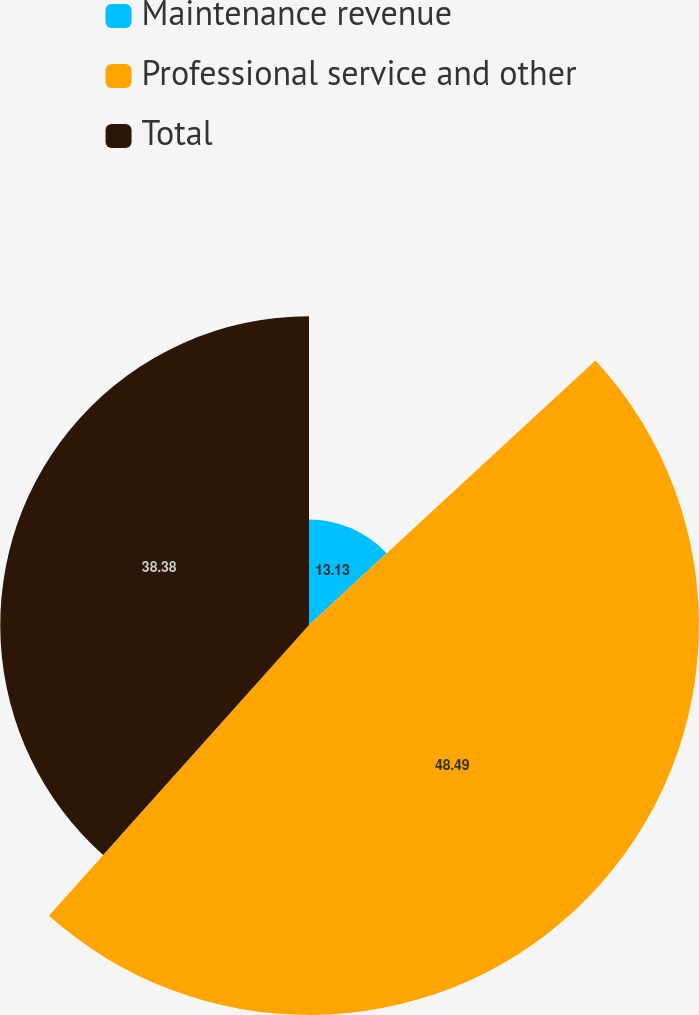Convert chart to OTSL. <chart><loc_0><loc_0><loc_500><loc_500><pie_chart><fcel>Maintenance revenue<fcel>Professional service and other<fcel>Total<nl><fcel>13.13%<fcel>48.48%<fcel>38.38%<nl></chart> 